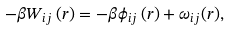Convert formula to latex. <formula><loc_0><loc_0><loc_500><loc_500>- \beta W _ { i j } \left ( r \right ) = - \beta \phi _ { i j } \left ( r \right ) + \omega _ { i j } ( r ) ,</formula> 